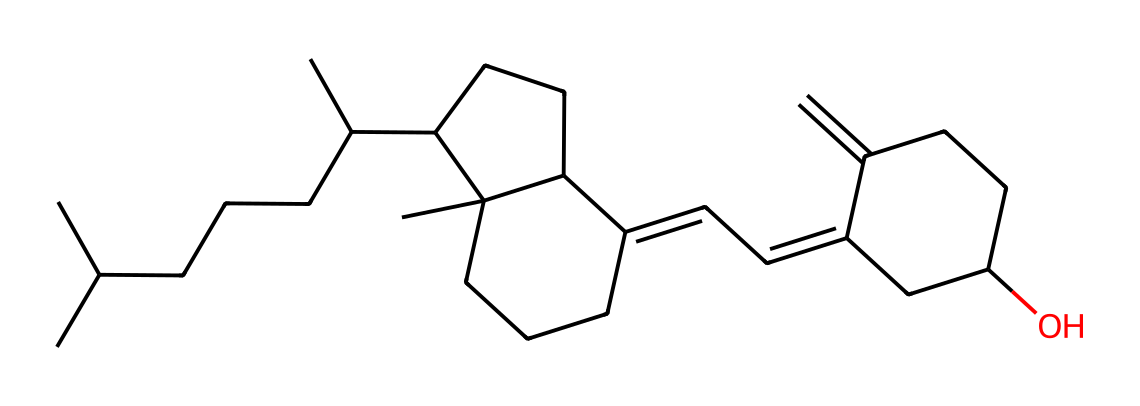What is the primary function of Vitamin D? Vitamin D is crucial for calcium absorption in the intestines, which is vital for maintaining bone health.
Answer: calcium absorption How many carbon atoms are in the Vitamin D molecule? Counting each 'C' in the SMILES, we find 27 carbon atoms in the molecule.
Answer: 27 What physical state is Vitamin D at room temperature? Vitamin D is a fat-soluble vitamin, typically solid at room temperature due to its molecular structure, which includes multiple carbon chains.
Answer: solid Does this molecule contain any oxygen atoms? The presence of 'O' in the SMILES indicates there is at least one oxygen atom in the chemical structure of Vitamin D.
Answer: yes What role does Vitamin D play for indoor workers? Indoor workers may have limited sun exposure, making Vitamin D essential for immune function and mood regulation despite the lack of natural sunlight.
Answer: immune function How do unsaturated bonds relate to the Vitamin D structure? The presence of the 'C=C' in the chemical structure signifies unsaturation; unsaturated bonds can affect the molecule's flexibility and reactivity.
Answer: affect flexibility 